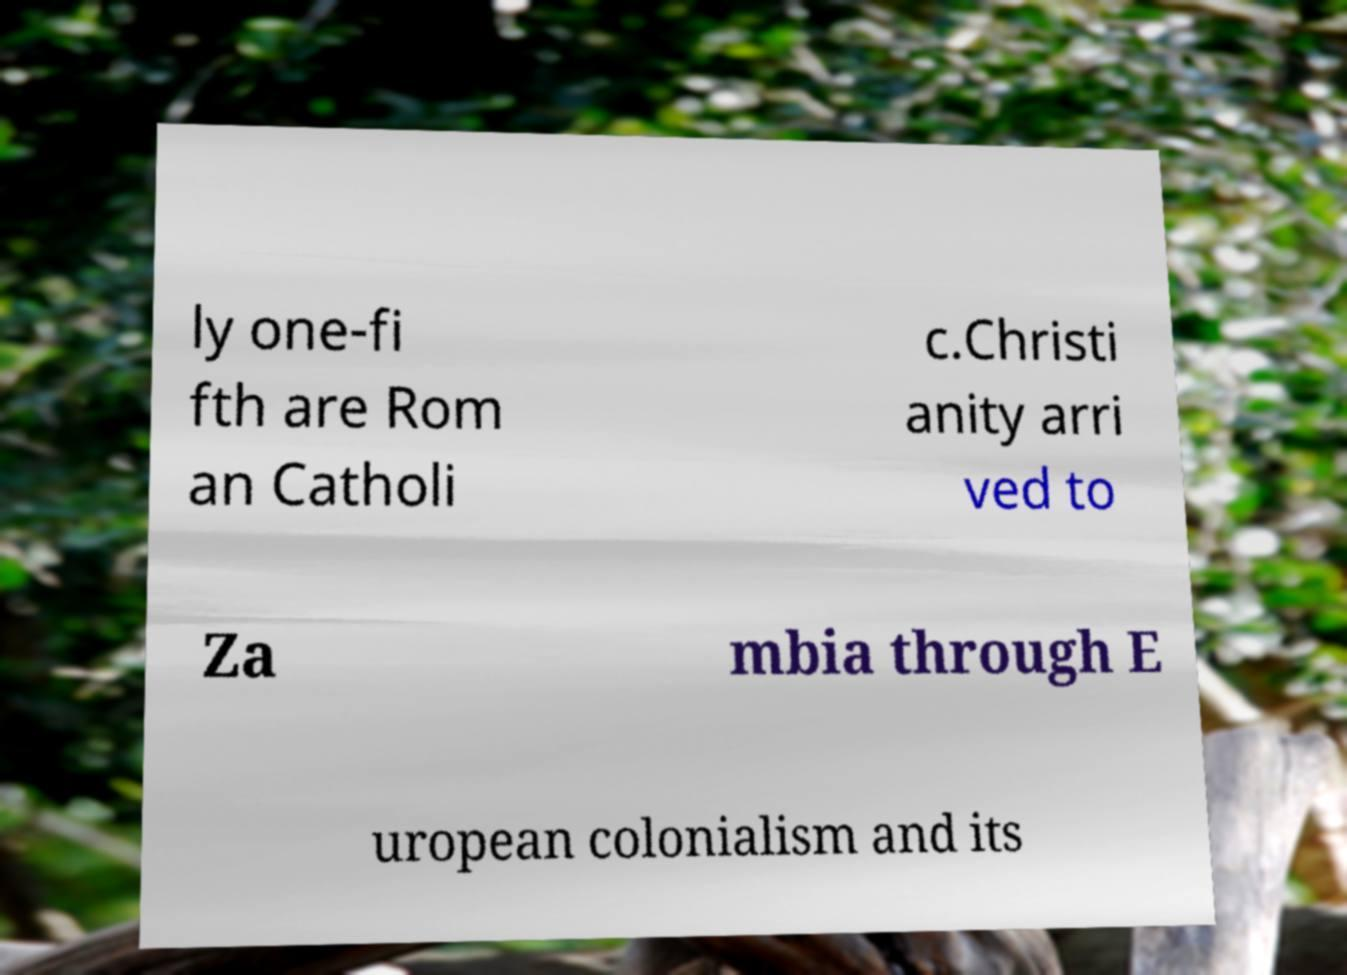I need the written content from this picture converted into text. Can you do that? ly one-fi fth are Rom an Catholi c.Christi anity arri ved to Za mbia through E uropean colonialism and its 